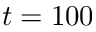<formula> <loc_0><loc_0><loc_500><loc_500>t = 1 0 0</formula> 